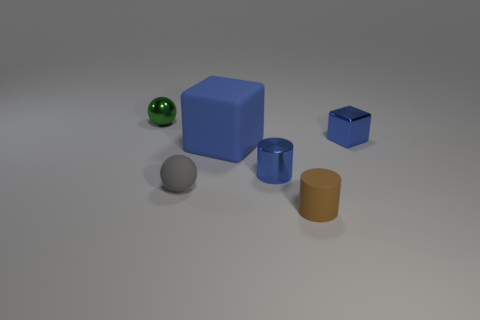What number of small matte objects are the same color as the metallic cylinder?
Keep it short and to the point. 0. There is a small sphere that is right of the metal thing that is to the left of the large rubber cube; are there any large blue cubes in front of it?
Your answer should be compact. No. What is the size of the rubber object that is to the right of the gray rubber object and in front of the small blue metal cylinder?
Keep it short and to the point. Small. How many other brown objects are the same material as the big thing?
Keep it short and to the point. 1. What number of spheres are brown rubber objects or blue matte objects?
Keep it short and to the point. 0. There is a metal object left of the tiny blue thing to the left of the thing that is in front of the small rubber sphere; what is its size?
Offer a very short reply. Small. What is the color of the small thing that is behind the large blue cube and in front of the green thing?
Provide a short and direct response. Blue. Does the blue shiny cylinder have the same size as the blue block that is on the left side of the brown thing?
Ensure brevity in your answer.  No. Is there any other thing that has the same shape as the small brown thing?
Ensure brevity in your answer.  Yes. What color is the other tiny thing that is the same shape as the tiny brown object?
Provide a succinct answer. Blue. 